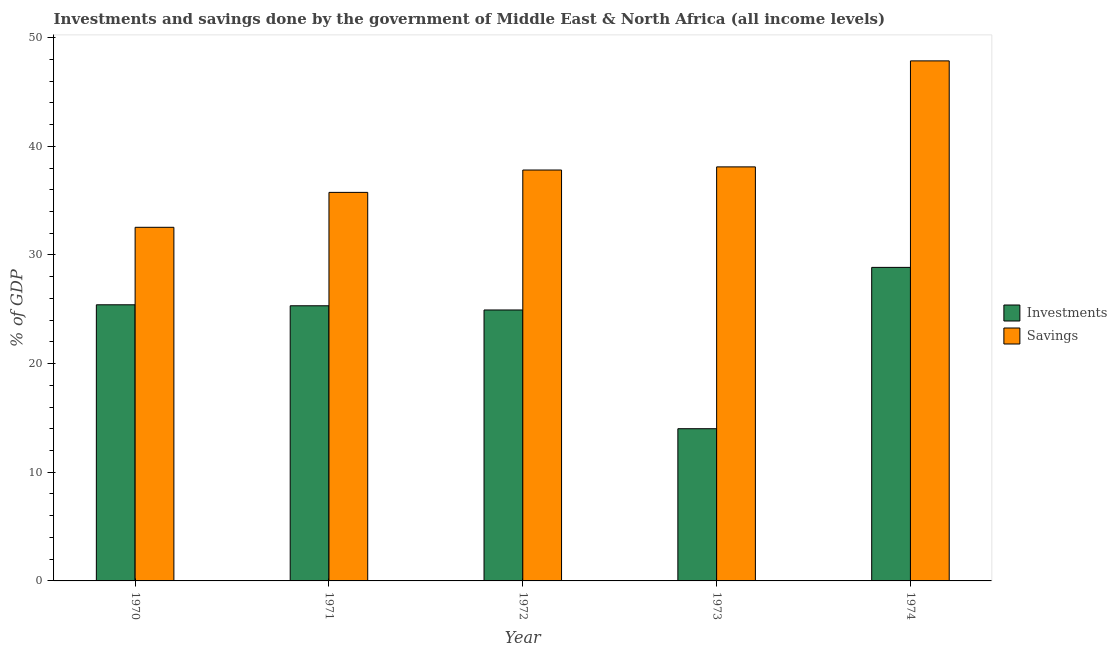How many groups of bars are there?
Your answer should be very brief. 5. Are the number of bars on each tick of the X-axis equal?
Offer a very short reply. Yes. How many bars are there on the 5th tick from the left?
Provide a succinct answer. 2. What is the savings of government in 1971?
Offer a terse response. 35.76. Across all years, what is the maximum investments of government?
Your answer should be compact. 28.85. Across all years, what is the minimum investments of government?
Offer a very short reply. 14.01. In which year was the investments of government maximum?
Ensure brevity in your answer.  1974. What is the total investments of government in the graph?
Your response must be concise. 118.53. What is the difference between the investments of government in 1971 and that in 1974?
Ensure brevity in your answer.  -3.53. What is the difference between the savings of government in 1971 and the investments of government in 1973?
Keep it short and to the point. -2.35. What is the average investments of government per year?
Offer a very short reply. 23.71. What is the ratio of the savings of government in 1971 to that in 1973?
Provide a succinct answer. 0.94. What is the difference between the highest and the second highest savings of government?
Give a very brief answer. 9.76. What is the difference between the highest and the lowest investments of government?
Offer a very short reply. 14.85. Is the sum of the savings of government in 1970 and 1974 greater than the maximum investments of government across all years?
Offer a very short reply. Yes. What does the 2nd bar from the left in 1972 represents?
Provide a succinct answer. Savings. What does the 2nd bar from the right in 1972 represents?
Offer a terse response. Investments. How many bars are there?
Your response must be concise. 10. Does the graph contain any zero values?
Make the answer very short. No. Where does the legend appear in the graph?
Provide a succinct answer. Center right. How many legend labels are there?
Your answer should be compact. 2. How are the legend labels stacked?
Provide a succinct answer. Vertical. What is the title of the graph?
Your answer should be very brief. Investments and savings done by the government of Middle East & North Africa (all income levels). Does "Research and Development" appear as one of the legend labels in the graph?
Provide a short and direct response. No. What is the label or title of the Y-axis?
Make the answer very short. % of GDP. What is the % of GDP of Investments in 1970?
Offer a terse response. 25.41. What is the % of GDP in Savings in 1970?
Your answer should be very brief. 32.54. What is the % of GDP of Investments in 1971?
Make the answer very short. 25.32. What is the % of GDP in Savings in 1971?
Provide a short and direct response. 35.76. What is the % of GDP in Investments in 1972?
Give a very brief answer. 24.93. What is the % of GDP of Savings in 1972?
Your response must be concise. 37.81. What is the % of GDP in Investments in 1973?
Your response must be concise. 14.01. What is the % of GDP in Savings in 1973?
Your answer should be compact. 38.1. What is the % of GDP of Investments in 1974?
Provide a succinct answer. 28.85. What is the % of GDP in Savings in 1974?
Your answer should be compact. 47.86. Across all years, what is the maximum % of GDP of Investments?
Provide a succinct answer. 28.85. Across all years, what is the maximum % of GDP of Savings?
Offer a terse response. 47.86. Across all years, what is the minimum % of GDP in Investments?
Provide a succinct answer. 14.01. Across all years, what is the minimum % of GDP in Savings?
Offer a terse response. 32.54. What is the total % of GDP of Investments in the graph?
Ensure brevity in your answer.  118.53. What is the total % of GDP in Savings in the graph?
Keep it short and to the point. 192.07. What is the difference between the % of GDP in Investments in 1970 and that in 1971?
Give a very brief answer. 0.09. What is the difference between the % of GDP of Savings in 1970 and that in 1971?
Your response must be concise. -3.21. What is the difference between the % of GDP of Investments in 1970 and that in 1972?
Give a very brief answer. 0.48. What is the difference between the % of GDP in Savings in 1970 and that in 1972?
Your answer should be very brief. -5.27. What is the difference between the % of GDP of Investments in 1970 and that in 1973?
Offer a very short reply. 11.4. What is the difference between the % of GDP in Savings in 1970 and that in 1973?
Provide a succinct answer. -5.56. What is the difference between the % of GDP of Investments in 1970 and that in 1974?
Your answer should be compact. -3.44. What is the difference between the % of GDP in Savings in 1970 and that in 1974?
Provide a succinct answer. -15.32. What is the difference between the % of GDP of Investments in 1971 and that in 1972?
Your answer should be very brief. 0.39. What is the difference between the % of GDP of Savings in 1971 and that in 1972?
Your answer should be very brief. -2.06. What is the difference between the % of GDP in Investments in 1971 and that in 1973?
Offer a very short reply. 11.31. What is the difference between the % of GDP in Savings in 1971 and that in 1973?
Your answer should be very brief. -2.35. What is the difference between the % of GDP in Investments in 1971 and that in 1974?
Provide a short and direct response. -3.53. What is the difference between the % of GDP of Savings in 1971 and that in 1974?
Your response must be concise. -12.1. What is the difference between the % of GDP of Investments in 1972 and that in 1973?
Offer a very short reply. 10.93. What is the difference between the % of GDP of Savings in 1972 and that in 1973?
Offer a very short reply. -0.29. What is the difference between the % of GDP in Investments in 1972 and that in 1974?
Your response must be concise. -3.92. What is the difference between the % of GDP in Savings in 1972 and that in 1974?
Ensure brevity in your answer.  -10.04. What is the difference between the % of GDP in Investments in 1973 and that in 1974?
Your response must be concise. -14.85. What is the difference between the % of GDP in Savings in 1973 and that in 1974?
Your answer should be compact. -9.76. What is the difference between the % of GDP in Investments in 1970 and the % of GDP in Savings in 1971?
Give a very brief answer. -10.34. What is the difference between the % of GDP in Investments in 1970 and the % of GDP in Savings in 1972?
Your answer should be very brief. -12.4. What is the difference between the % of GDP in Investments in 1970 and the % of GDP in Savings in 1973?
Give a very brief answer. -12.69. What is the difference between the % of GDP in Investments in 1970 and the % of GDP in Savings in 1974?
Your response must be concise. -22.45. What is the difference between the % of GDP of Investments in 1971 and the % of GDP of Savings in 1972?
Provide a short and direct response. -12.49. What is the difference between the % of GDP in Investments in 1971 and the % of GDP in Savings in 1973?
Keep it short and to the point. -12.78. What is the difference between the % of GDP in Investments in 1971 and the % of GDP in Savings in 1974?
Provide a short and direct response. -22.54. What is the difference between the % of GDP of Investments in 1972 and the % of GDP of Savings in 1973?
Offer a terse response. -13.17. What is the difference between the % of GDP of Investments in 1972 and the % of GDP of Savings in 1974?
Your answer should be very brief. -22.92. What is the difference between the % of GDP of Investments in 1973 and the % of GDP of Savings in 1974?
Your answer should be very brief. -33.85. What is the average % of GDP in Investments per year?
Make the answer very short. 23.71. What is the average % of GDP in Savings per year?
Keep it short and to the point. 38.41. In the year 1970, what is the difference between the % of GDP of Investments and % of GDP of Savings?
Make the answer very short. -7.13. In the year 1971, what is the difference between the % of GDP in Investments and % of GDP in Savings?
Provide a succinct answer. -10.44. In the year 1972, what is the difference between the % of GDP of Investments and % of GDP of Savings?
Your answer should be compact. -12.88. In the year 1973, what is the difference between the % of GDP in Investments and % of GDP in Savings?
Provide a succinct answer. -24.1. In the year 1974, what is the difference between the % of GDP in Investments and % of GDP in Savings?
Ensure brevity in your answer.  -19. What is the ratio of the % of GDP in Investments in 1970 to that in 1971?
Offer a terse response. 1. What is the ratio of the % of GDP in Savings in 1970 to that in 1971?
Provide a succinct answer. 0.91. What is the ratio of the % of GDP of Investments in 1970 to that in 1972?
Provide a short and direct response. 1.02. What is the ratio of the % of GDP of Savings in 1970 to that in 1972?
Your answer should be very brief. 0.86. What is the ratio of the % of GDP of Investments in 1970 to that in 1973?
Offer a very short reply. 1.81. What is the ratio of the % of GDP in Savings in 1970 to that in 1973?
Provide a succinct answer. 0.85. What is the ratio of the % of GDP of Investments in 1970 to that in 1974?
Offer a very short reply. 0.88. What is the ratio of the % of GDP in Savings in 1970 to that in 1974?
Keep it short and to the point. 0.68. What is the ratio of the % of GDP in Investments in 1971 to that in 1972?
Provide a short and direct response. 1.02. What is the ratio of the % of GDP of Savings in 1971 to that in 1972?
Offer a terse response. 0.95. What is the ratio of the % of GDP in Investments in 1971 to that in 1973?
Provide a succinct answer. 1.81. What is the ratio of the % of GDP of Savings in 1971 to that in 1973?
Your answer should be very brief. 0.94. What is the ratio of the % of GDP in Investments in 1971 to that in 1974?
Provide a succinct answer. 0.88. What is the ratio of the % of GDP in Savings in 1971 to that in 1974?
Give a very brief answer. 0.75. What is the ratio of the % of GDP in Investments in 1972 to that in 1973?
Provide a succinct answer. 1.78. What is the ratio of the % of GDP of Investments in 1972 to that in 1974?
Keep it short and to the point. 0.86. What is the ratio of the % of GDP in Savings in 1972 to that in 1974?
Offer a very short reply. 0.79. What is the ratio of the % of GDP in Investments in 1973 to that in 1974?
Offer a very short reply. 0.49. What is the ratio of the % of GDP in Savings in 1973 to that in 1974?
Ensure brevity in your answer.  0.8. What is the difference between the highest and the second highest % of GDP of Investments?
Your answer should be very brief. 3.44. What is the difference between the highest and the second highest % of GDP in Savings?
Your response must be concise. 9.76. What is the difference between the highest and the lowest % of GDP of Investments?
Your answer should be compact. 14.85. What is the difference between the highest and the lowest % of GDP in Savings?
Ensure brevity in your answer.  15.32. 